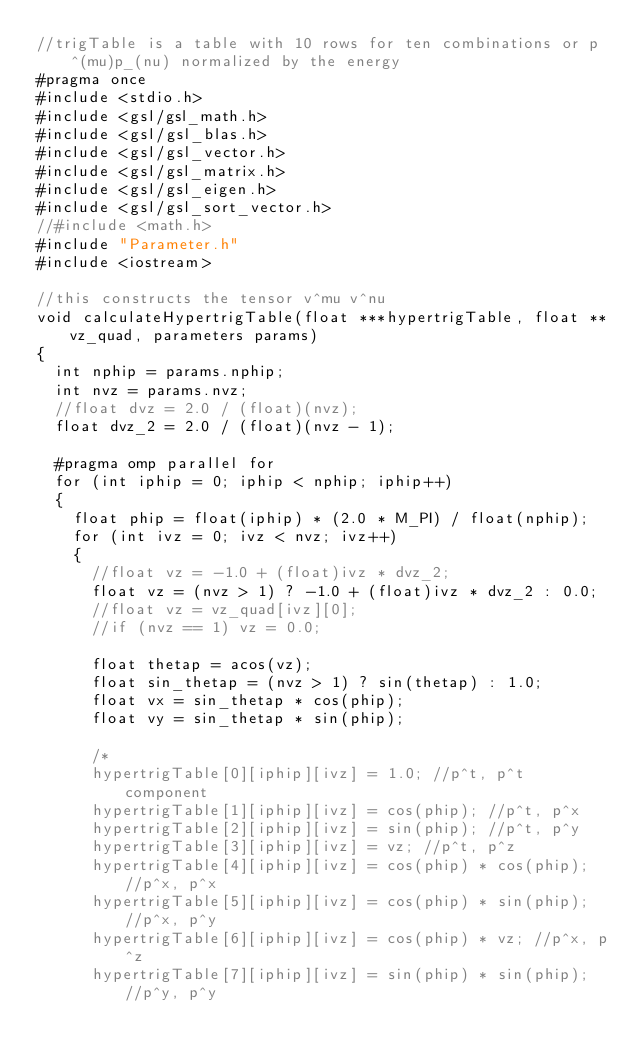Convert code to text. <code><loc_0><loc_0><loc_500><loc_500><_C++_>//trigTable is a table with 10 rows for ten combinations or p^(mu)p_(nu) normalized by the energy
#pragma once
#include <stdio.h>
#include <gsl/gsl_math.h>
#include <gsl/gsl_blas.h>
#include <gsl/gsl_vector.h>
#include <gsl/gsl_matrix.h>
#include <gsl/gsl_eigen.h>
#include <gsl/gsl_sort_vector.h>
//#include <math.h>
#include "Parameter.h"
#include <iostream>

//this constructs the tensor v^mu v^nu
void calculateHypertrigTable(float ***hypertrigTable, float **vz_quad, parameters params)
{
  int nphip = params.nphip;
  int nvz = params.nvz;
  //float dvz = 2.0 / (float)(nvz);
  float dvz_2 = 2.0 / (float)(nvz - 1);

  #pragma omp parallel for
  for (int iphip = 0; iphip < nphip; iphip++)
  {
    float phip = float(iphip) * (2.0 * M_PI) / float(nphip);
    for (int ivz = 0; ivz < nvz; ivz++)
    {
      //float vz = -1.0 + (float)ivz * dvz_2;
      float vz = (nvz > 1) ? -1.0 + (float)ivz * dvz_2 : 0.0;
      //float vz = vz_quad[ivz][0];
      //if (nvz == 1) vz = 0.0;

      float thetap = acos(vz);
      float sin_thetap = (nvz > 1) ? sin(thetap) : 1.0;
      float vx = sin_thetap * cos(phip);
      float vy = sin_thetap * sin(phip);

      /*
      hypertrigTable[0][iphip][ivz] = 1.0; //p^t, p^t component
      hypertrigTable[1][iphip][ivz] = cos(phip); //p^t, p^x
      hypertrigTable[2][iphip][ivz] = sin(phip); //p^t, p^y
      hypertrigTable[3][iphip][ivz] = vz; //p^t, p^z
      hypertrigTable[4][iphip][ivz] = cos(phip) * cos(phip); //p^x, p^x
      hypertrigTable[5][iphip][ivz] = cos(phip) * sin(phip); //p^x, p^y
      hypertrigTable[6][iphip][ivz] = cos(phip) * vz; //p^x, p^z
      hypertrigTable[7][iphip][ivz] = sin(phip) * sin(phip); //p^y, p^y</code> 